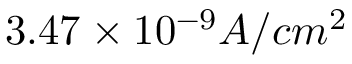Convert formula to latex. <formula><loc_0><loc_0><loc_500><loc_500>3 . 4 7 \times 1 0 ^ { - 9 } A / c m ^ { 2 }</formula> 